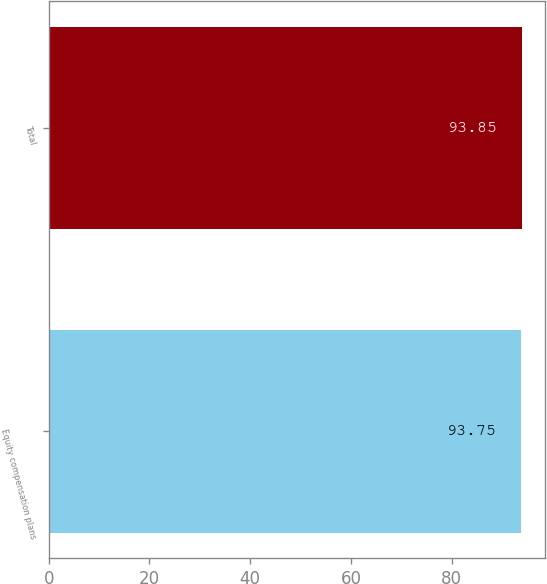<chart> <loc_0><loc_0><loc_500><loc_500><bar_chart><fcel>Equity compensation plans<fcel>Total<nl><fcel>93.75<fcel>93.85<nl></chart> 